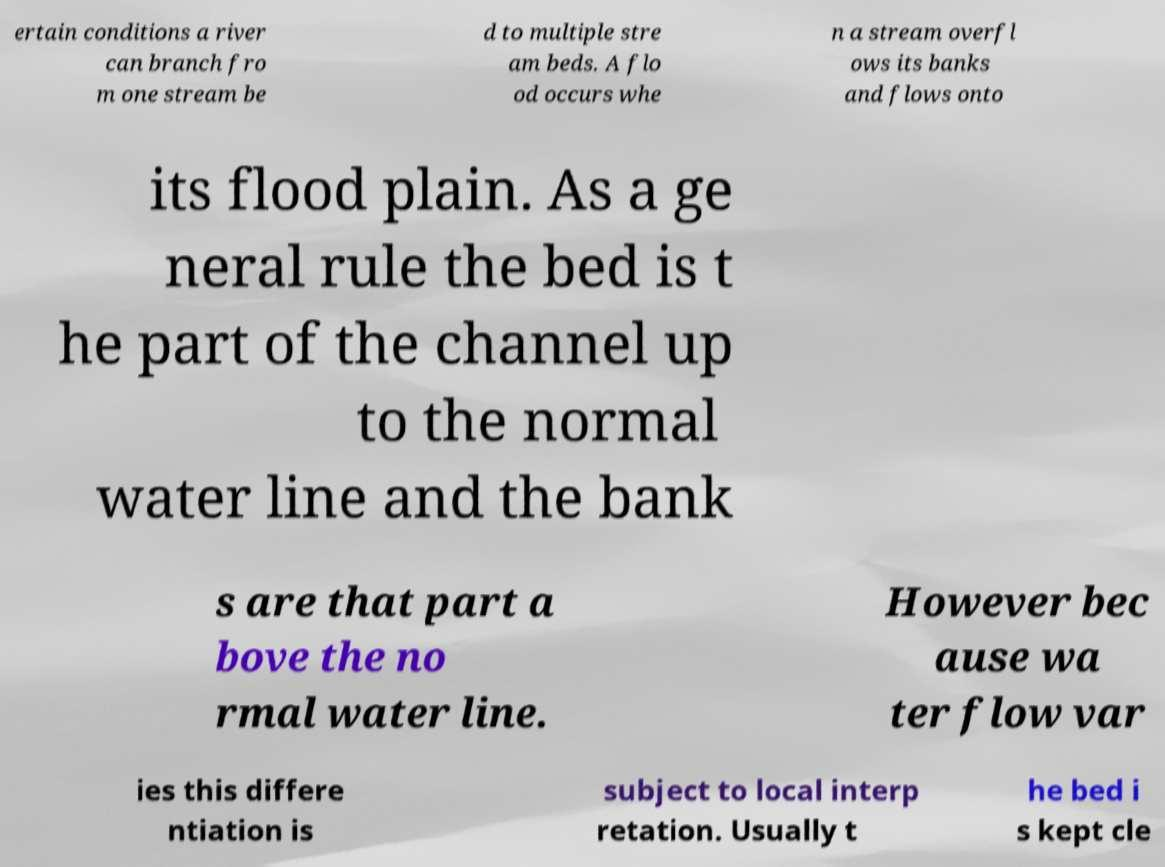For documentation purposes, I need the text within this image transcribed. Could you provide that? ertain conditions a river can branch fro m one stream be d to multiple stre am beds. A flo od occurs whe n a stream overfl ows its banks and flows onto its flood plain. As a ge neral rule the bed is t he part of the channel up to the normal water line and the bank s are that part a bove the no rmal water line. However bec ause wa ter flow var ies this differe ntiation is subject to local interp retation. Usually t he bed i s kept cle 